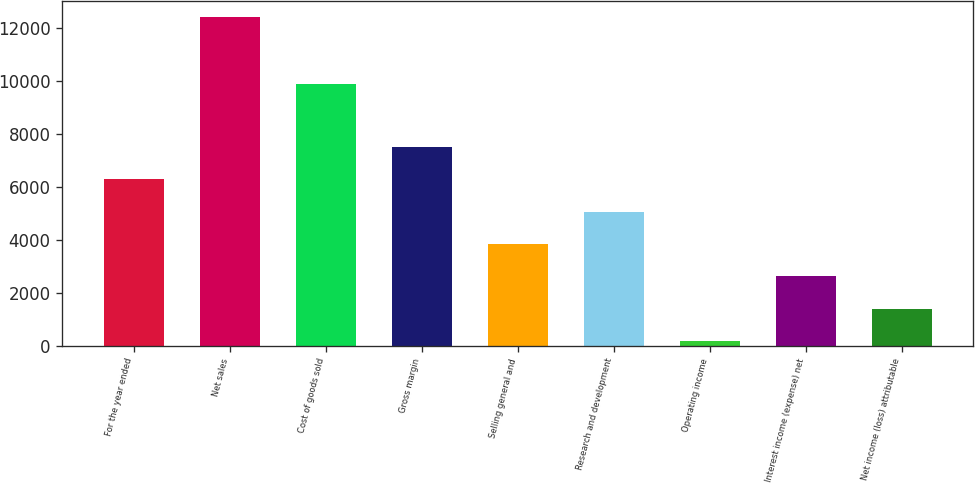Convert chart to OTSL. <chart><loc_0><loc_0><loc_500><loc_500><bar_chart><fcel>For the year ended<fcel>Net sales<fcel>Cost of goods sold<fcel>Gross margin<fcel>Selling general and<fcel>Research and development<fcel>Operating income<fcel>Interest income (expense) net<fcel>Net income (loss) attributable<nl><fcel>6283.5<fcel>12399<fcel>9894<fcel>7506.6<fcel>3837.3<fcel>5060.4<fcel>168<fcel>2614.2<fcel>1391.1<nl></chart> 